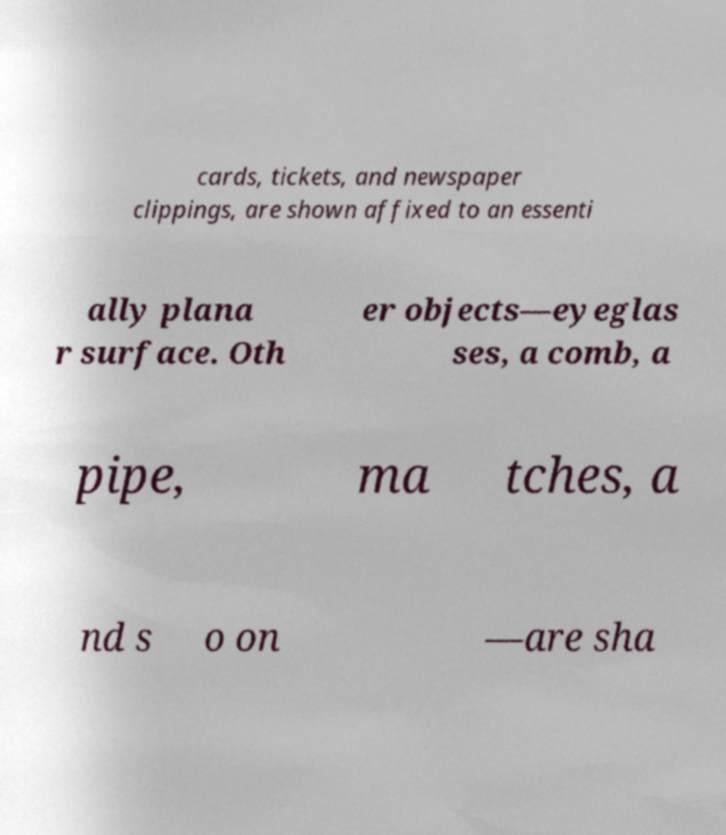I need the written content from this picture converted into text. Can you do that? cards, tickets, and newspaper clippings, are shown affixed to an essenti ally plana r surface. Oth er objects—eyeglas ses, a comb, a pipe, ma tches, a nd s o on —are sha 